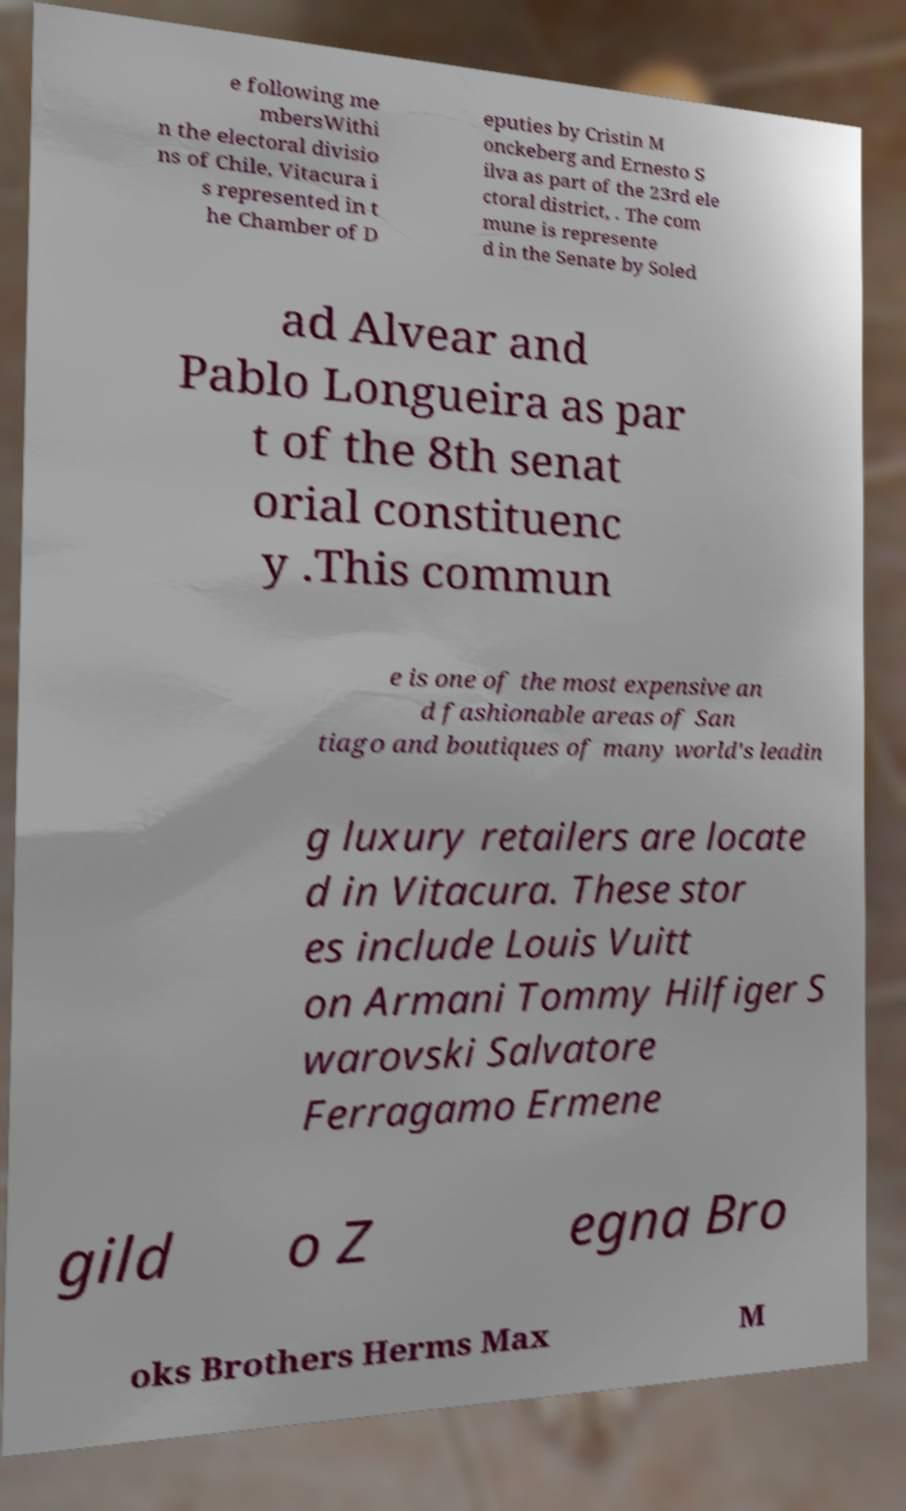Could you extract and type out the text from this image? e following me mbersWithi n the electoral divisio ns of Chile, Vitacura i s represented in t he Chamber of D eputies by Cristin M onckeberg and Ernesto S ilva as part of the 23rd ele ctoral district, . The com mune is represente d in the Senate by Soled ad Alvear and Pablo Longueira as par t of the 8th senat orial constituenc y .This commun e is one of the most expensive an d fashionable areas of San tiago and boutiques of many world's leadin g luxury retailers are locate d in Vitacura. These stor es include Louis Vuitt on Armani Tommy Hilfiger S warovski Salvatore Ferragamo Ermene gild o Z egna Bro oks Brothers Herms Max M 